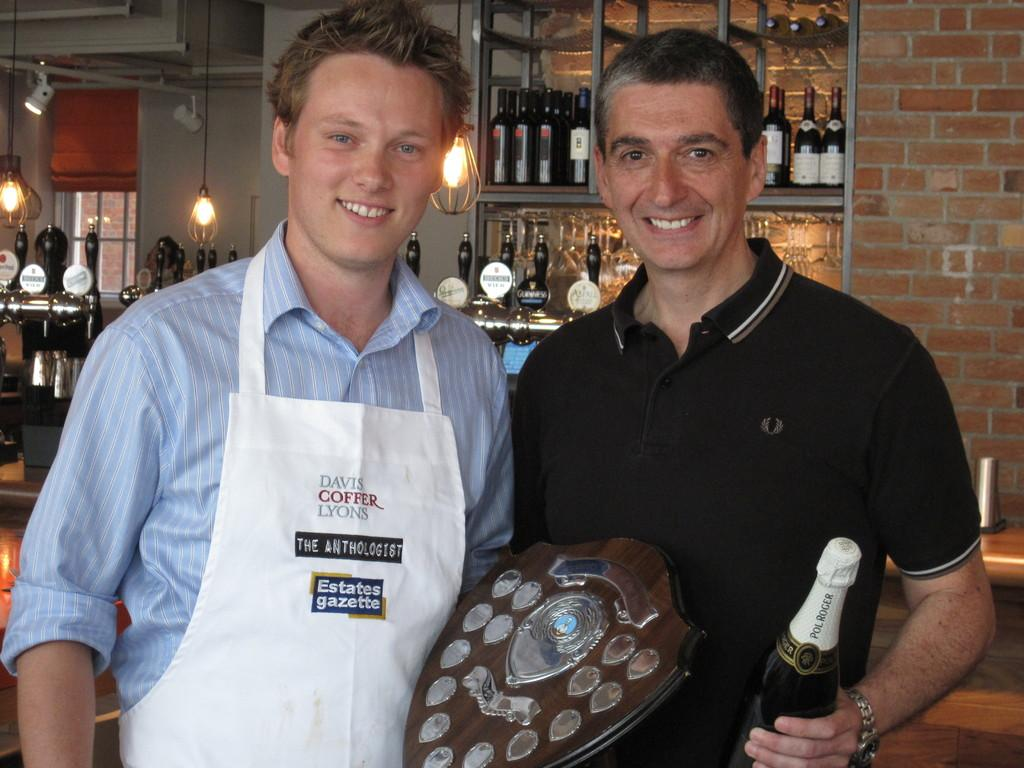How many people are in the image? There are two men in the image. What are the men doing in the image? The men are standing and holding a prize and a bottle in their hands. What can be seen in the background of the image? There are wine bottles in a rack in the background. Is there any source of light in the image? Yes, there is a light in the image. What type of zinc can be smelled in the image? There is no zinc present in the image, and therefore no smell can be associated with it. What type of coil is visible in the image? There is no coil visible in the image. 